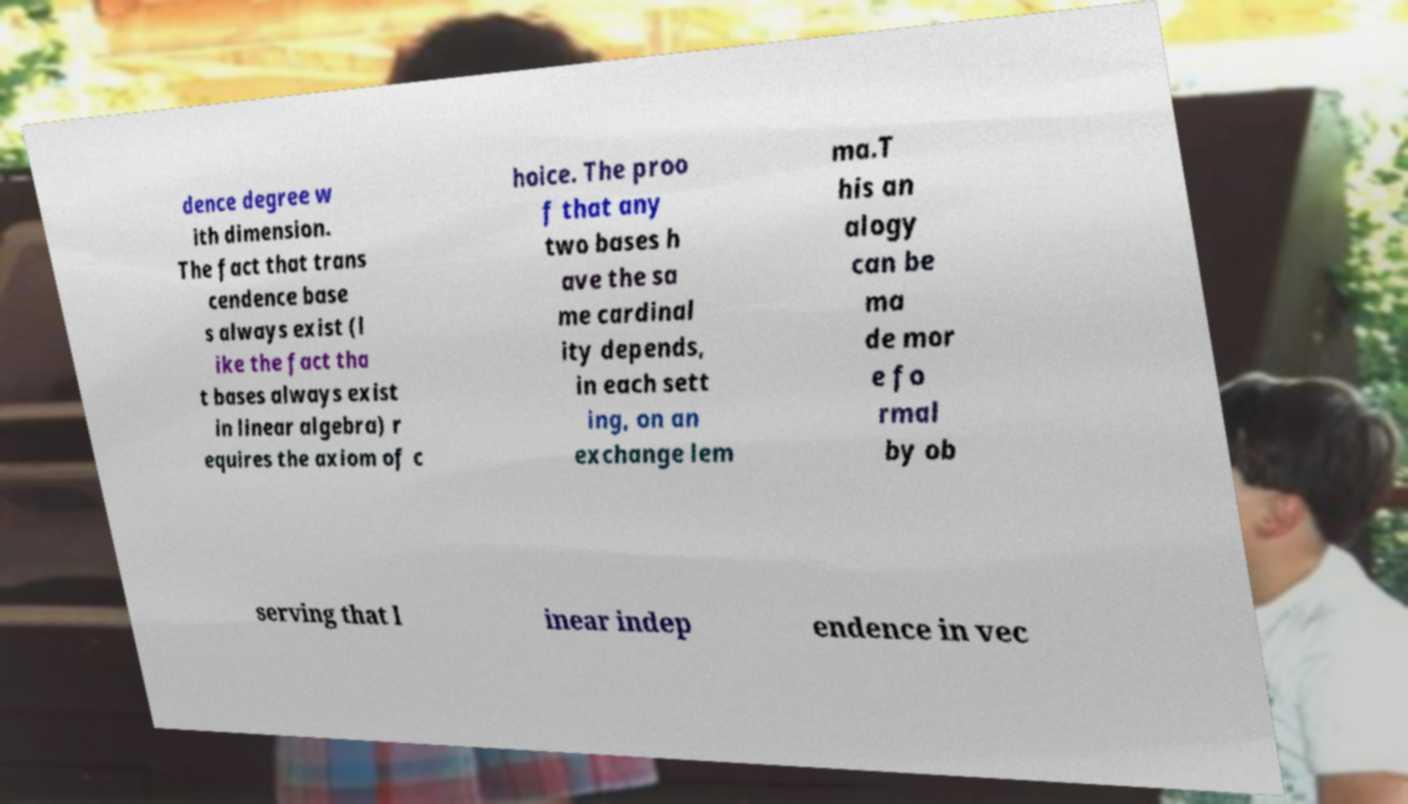I need the written content from this picture converted into text. Can you do that? dence degree w ith dimension. The fact that trans cendence base s always exist (l ike the fact tha t bases always exist in linear algebra) r equires the axiom of c hoice. The proo f that any two bases h ave the sa me cardinal ity depends, in each sett ing, on an exchange lem ma.T his an alogy can be ma de mor e fo rmal by ob serving that l inear indep endence in vec 